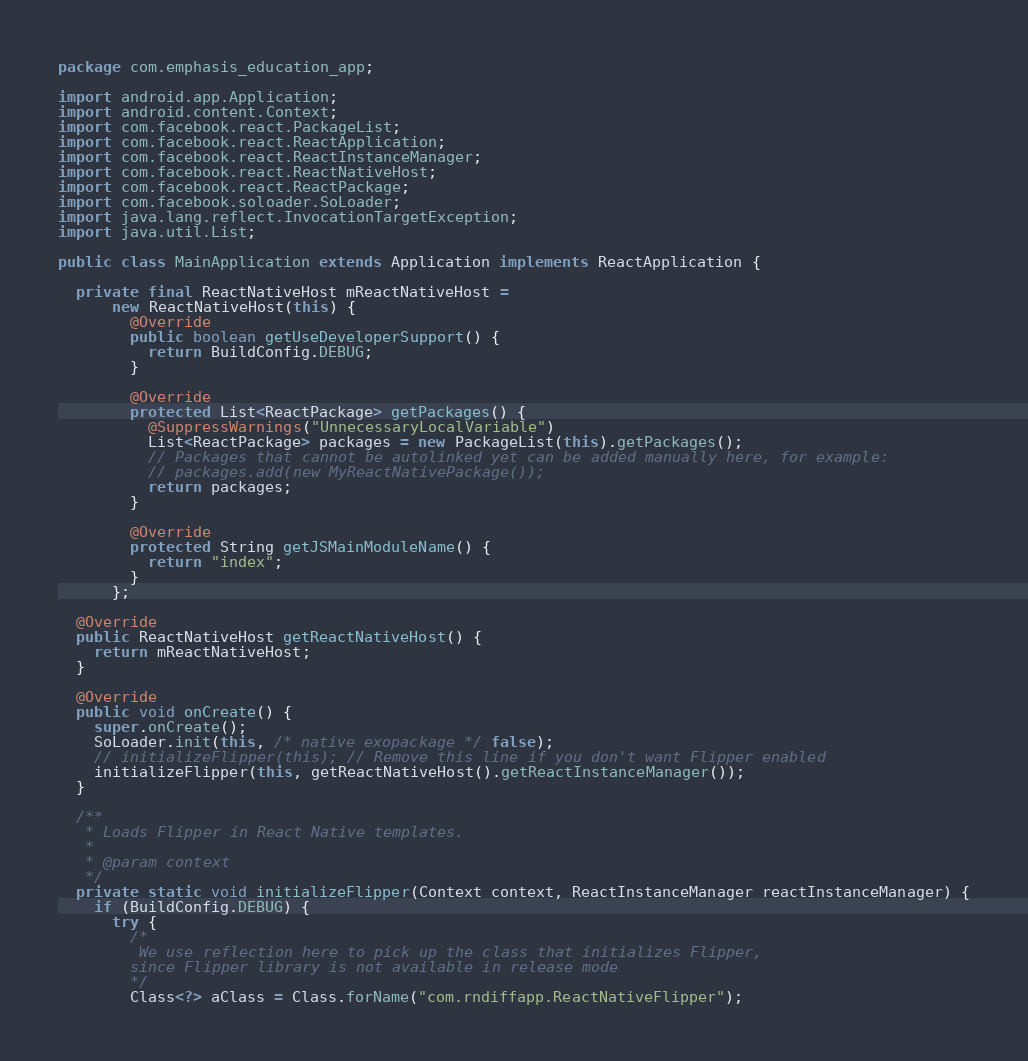Convert code to text. <code><loc_0><loc_0><loc_500><loc_500><_Java_>package com.emphasis_education_app;

import android.app.Application;
import android.content.Context;
import com.facebook.react.PackageList;
import com.facebook.react.ReactApplication;
import com.facebook.react.ReactInstanceManager;
import com.facebook.react.ReactNativeHost;
import com.facebook.react.ReactPackage;
import com.facebook.soloader.SoLoader;
import java.lang.reflect.InvocationTargetException;
import java.util.List;

public class MainApplication extends Application implements ReactApplication {

  private final ReactNativeHost mReactNativeHost =
      new ReactNativeHost(this) {
        @Override
        public boolean getUseDeveloperSupport() {
          return BuildConfig.DEBUG;
        }

        @Override
        protected List<ReactPackage> getPackages() {
          @SuppressWarnings("UnnecessaryLocalVariable")
          List<ReactPackage> packages = new PackageList(this).getPackages();
          // Packages that cannot be autolinked yet can be added manually here, for example:
          // packages.add(new MyReactNativePackage());
          return packages;
        }

        @Override
        protected String getJSMainModuleName() {
          return "index";
        }
      };

  @Override
  public ReactNativeHost getReactNativeHost() {
    return mReactNativeHost;
  }

  @Override
  public void onCreate() {
    super.onCreate();
    SoLoader.init(this, /* native exopackage */ false);
    // initializeFlipper(this); // Remove this line if you don't want Flipper enabled
    initializeFlipper(this, getReactNativeHost().getReactInstanceManager());
  }

  /**
   * Loads Flipper in React Native templates.
   *
   * @param context
   */
  private static void initializeFlipper(Context context, ReactInstanceManager reactInstanceManager) {
    if (BuildConfig.DEBUG) {
      try {
        /*
         We use reflection here to pick up the class that initializes Flipper,
        since Flipper library is not available in release mode
        */
        Class<?> aClass = Class.forName("com.rndiffapp.ReactNativeFlipper");</code> 